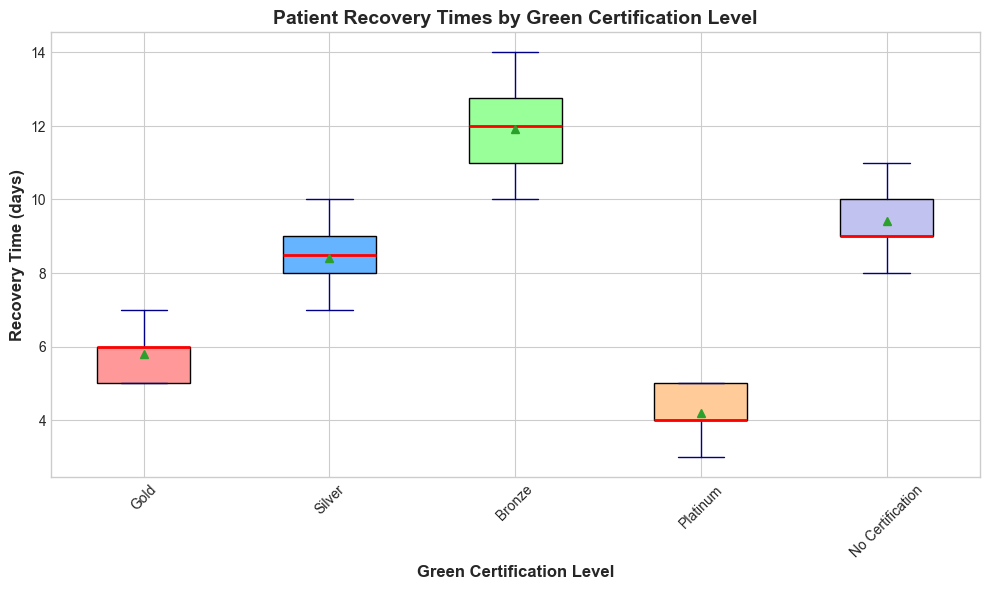What is the median recovery time for Platinum-certified hospitals? Look at the red line inside the box plot for Platinum-certified hospitals. The red line corresponds to the median value.
Answer: 4 Which certification level has the lowest mean recovery time? Identify the central marker within each box plot, represented by a small circle. The box plot with the lowest mean recovery time is the one where the central marker is the closest to the bottom.
Answer: Platinum What is the interquartile range (IQR) for Bronze-certified hospitals? The IQR is the difference between the third quartile (top edge of the box) and the first quartile (bottom edge of the box). Measure these points on the y-axis to calculate the IQR.
Answer: 2 Which certification level has the smallest range in recovery times? Identify the range by observing the length from the top whisker to the bottom whisker. The certification level with the shortest total spread between these points has the smallest range.
Answer: Gold How does the median recovery time for Gold-certified hospitals compare to Silver-certified hospitals? Identify the red lines in the Gold and Silver box plots and compare their y-axis positions. The relative height of these lines will indicate which median is higher.
Answer: Gold is lower Is there any overlap in the recovery times between Platinum and No Certification hospitals? Compare the extent of the whiskers and boxes for both Platinum and No Certification hospitals. If the ranges of these box plots overlap on the y-axis, then they overlap in recovery times.
Answer: No Which certified level shows the highest variability in recovery times? Variability is shown by the length of the box (IQR) and the whiskers. The certification level with the longest box and whiskers indicates the highest variability.
Answer: Bronze How does the upper quartile (Q3) of Silver compare to the upper quartile of Bronze certification levels? The upper quartile (Q3) is the top edge of the box. Determine the positions of these top edges on the y-axis for both Silver and Bronze certification levels and compare.
Answer: Silver is lower What is the range of recovery times for No Certification hospitals? Identify the highest and lowest points represented by the whiskers for No Certification hospitals and calculate the difference.
Answer: 3 Which certification level has the narrowest box, indicating the least interquartile variability? Look for the box with the shortest height from the bottom to the top edge (first to third quartile). The narrowest box indicates the least IQR.
Answer: Gold 